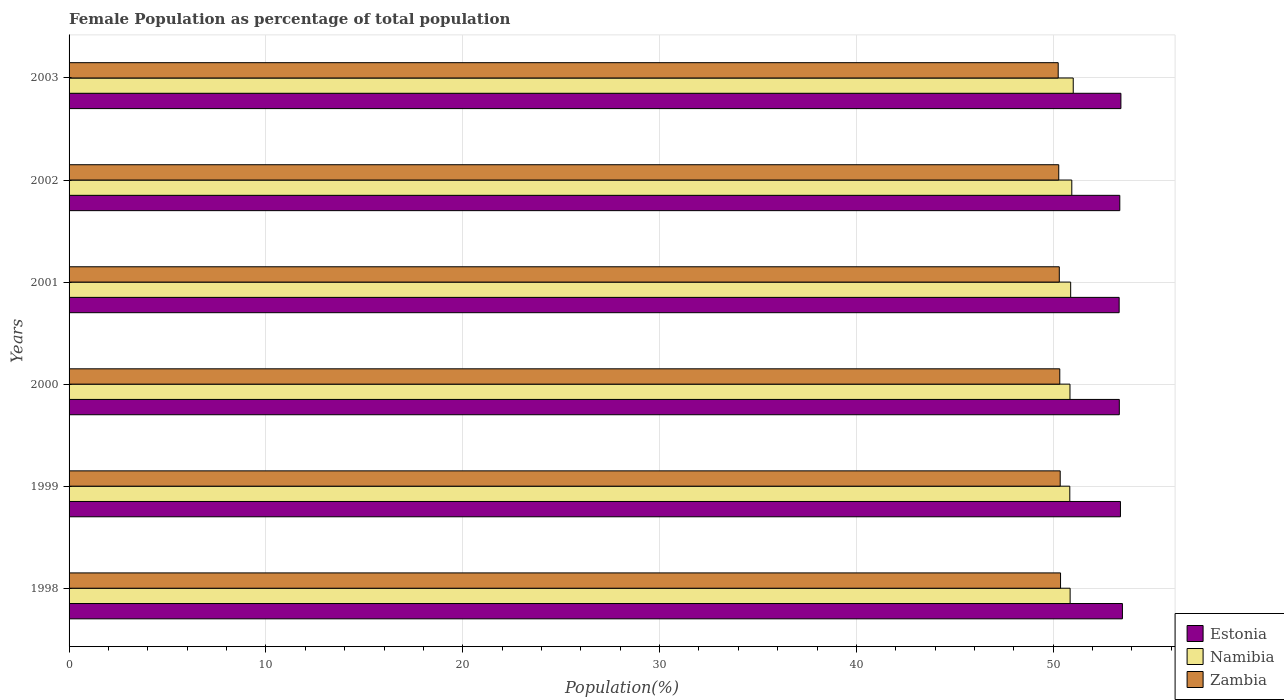Are the number of bars per tick equal to the number of legend labels?
Give a very brief answer. Yes. How many bars are there on the 2nd tick from the bottom?
Make the answer very short. 3. What is the label of the 3rd group of bars from the top?
Your answer should be compact. 2001. What is the female population in in Zambia in 2003?
Provide a short and direct response. 50.25. Across all years, what is the maximum female population in in Namibia?
Offer a very short reply. 51.02. Across all years, what is the minimum female population in in Zambia?
Offer a terse response. 50.25. In which year was the female population in in Estonia maximum?
Offer a very short reply. 1998. What is the total female population in in Zambia in the graph?
Your response must be concise. 301.91. What is the difference between the female population in in Namibia in 1998 and that in 2000?
Your answer should be very brief. 0.01. What is the difference between the female population in in Estonia in 1998 and the female population in in Zambia in 1999?
Keep it short and to the point. 3.16. What is the average female population in in Zambia per year?
Keep it short and to the point. 50.32. In the year 2000, what is the difference between the female population in in Namibia and female population in in Zambia?
Make the answer very short. 0.52. In how many years, is the female population in in Namibia greater than 20 %?
Your answer should be very brief. 6. What is the ratio of the female population in in Zambia in 1998 to that in 1999?
Provide a short and direct response. 1. Is the difference between the female population in in Namibia in 1999 and 2000 greater than the difference between the female population in in Zambia in 1999 and 2000?
Make the answer very short. No. What is the difference between the highest and the second highest female population in in Namibia?
Keep it short and to the point. 0.07. What is the difference between the highest and the lowest female population in in Namibia?
Make the answer very short. 0.17. What does the 2nd bar from the top in 1998 represents?
Ensure brevity in your answer.  Namibia. What does the 3rd bar from the bottom in 2000 represents?
Offer a very short reply. Zambia. Is it the case that in every year, the sum of the female population in in Namibia and female population in in Zambia is greater than the female population in in Estonia?
Give a very brief answer. Yes. How many bars are there?
Offer a terse response. 18. Are all the bars in the graph horizontal?
Keep it short and to the point. Yes. How many years are there in the graph?
Give a very brief answer. 6. What is the difference between two consecutive major ticks on the X-axis?
Provide a short and direct response. 10. Does the graph contain any zero values?
Your answer should be very brief. No. Does the graph contain grids?
Ensure brevity in your answer.  Yes. Where does the legend appear in the graph?
Your answer should be very brief. Bottom right. How are the legend labels stacked?
Offer a very short reply. Vertical. What is the title of the graph?
Make the answer very short. Female Population as percentage of total population. Does "European Union" appear as one of the legend labels in the graph?
Offer a terse response. No. What is the label or title of the X-axis?
Offer a terse response. Population(%). What is the Population(%) of Estonia in 1998?
Make the answer very short. 53.52. What is the Population(%) in Namibia in 1998?
Your response must be concise. 50.86. What is the Population(%) in Zambia in 1998?
Give a very brief answer. 50.37. What is the Population(%) in Estonia in 1999?
Your answer should be very brief. 53.42. What is the Population(%) of Namibia in 1999?
Provide a succinct answer. 50.84. What is the Population(%) of Zambia in 1999?
Give a very brief answer. 50.36. What is the Population(%) of Estonia in 2000?
Your response must be concise. 53.36. What is the Population(%) in Namibia in 2000?
Provide a short and direct response. 50.85. What is the Population(%) in Zambia in 2000?
Your answer should be compact. 50.33. What is the Population(%) of Estonia in 2001?
Make the answer very short. 53.35. What is the Population(%) in Namibia in 2001?
Your answer should be compact. 50.89. What is the Population(%) of Zambia in 2001?
Provide a succinct answer. 50.31. What is the Population(%) of Estonia in 2002?
Your answer should be compact. 53.38. What is the Population(%) in Namibia in 2002?
Your response must be concise. 50.94. What is the Population(%) of Zambia in 2002?
Keep it short and to the point. 50.28. What is the Population(%) of Estonia in 2003?
Your answer should be very brief. 53.44. What is the Population(%) in Namibia in 2003?
Provide a succinct answer. 51.02. What is the Population(%) in Zambia in 2003?
Provide a succinct answer. 50.25. Across all years, what is the maximum Population(%) of Estonia?
Keep it short and to the point. 53.52. Across all years, what is the maximum Population(%) of Namibia?
Provide a succinct answer. 51.02. Across all years, what is the maximum Population(%) in Zambia?
Offer a very short reply. 50.37. Across all years, what is the minimum Population(%) of Estonia?
Your answer should be compact. 53.35. Across all years, what is the minimum Population(%) of Namibia?
Provide a succinct answer. 50.84. Across all years, what is the minimum Population(%) in Zambia?
Your response must be concise. 50.25. What is the total Population(%) in Estonia in the graph?
Provide a succinct answer. 320.47. What is the total Population(%) of Namibia in the graph?
Make the answer very short. 305.41. What is the total Population(%) in Zambia in the graph?
Provide a succinct answer. 301.91. What is the difference between the Population(%) of Estonia in 1998 and that in 1999?
Make the answer very short. 0.1. What is the difference between the Population(%) in Namibia in 1998 and that in 1999?
Your response must be concise. 0.02. What is the difference between the Population(%) in Zambia in 1998 and that in 1999?
Your answer should be very brief. 0.02. What is the difference between the Population(%) of Estonia in 1998 and that in 2000?
Your response must be concise. 0.16. What is the difference between the Population(%) of Namibia in 1998 and that in 2000?
Provide a succinct answer. 0.01. What is the difference between the Population(%) in Zambia in 1998 and that in 2000?
Your answer should be compact. 0.04. What is the difference between the Population(%) in Estonia in 1998 and that in 2001?
Your response must be concise. 0.17. What is the difference between the Population(%) of Namibia in 1998 and that in 2001?
Make the answer very short. -0.03. What is the difference between the Population(%) in Zambia in 1998 and that in 2001?
Provide a succinct answer. 0.06. What is the difference between the Population(%) of Estonia in 1998 and that in 2002?
Your answer should be very brief. 0.13. What is the difference between the Population(%) of Namibia in 1998 and that in 2002?
Your answer should be compact. -0.09. What is the difference between the Population(%) of Zambia in 1998 and that in 2002?
Your response must be concise. 0.09. What is the difference between the Population(%) in Estonia in 1998 and that in 2003?
Your response must be concise. 0.08. What is the difference between the Population(%) in Namibia in 1998 and that in 2003?
Offer a very short reply. -0.16. What is the difference between the Population(%) of Zambia in 1998 and that in 2003?
Provide a short and direct response. 0.12. What is the difference between the Population(%) of Estonia in 1999 and that in 2000?
Offer a terse response. 0.06. What is the difference between the Population(%) of Namibia in 1999 and that in 2000?
Your answer should be very brief. -0.01. What is the difference between the Population(%) in Zambia in 1999 and that in 2000?
Your response must be concise. 0.02. What is the difference between the Population(%) in Estonia in 1999 and that in 2001?
Your answer should be very brief. 0.07. What is the difference between the Population(%) in Namibia in 1999 and that in 2001?
Ensure brevity in your answer.  -0.04. What is the difference between the Population(%) of Zambia in 1999 and that in 2001?
Provide a succinct answer. 0.05. What is the difference between the Population(%) of Estonia in 1999 and that in 2002?
Make the answer very short. 0.03. What is the difference between the Population(%) of Namibia in 1999 and that in 2002?
Your answer should be very brief. -0.1. What is the difference between the Population(%) of Zambia in 1999 and that in 2002?
Give a very brief answer. 0.07. What is the difference between the Population(%) in Estonia in 1999 and that in 2003?
Your answer should be compact. -0.02. What is the difference between the Population(%) in Namibia in 1999 and that in 2003?
Your answer should be very brief. -0.17. What is the difference between the Population(%) in Zambia in 1999 and that in 2003?
Your response must be concise. 0.1. What is the difference between the Population(%) of Estonia in 2000 and that in 2001?
Provide a succinct answer. 0.01. What is the difference between the Population(%) of Namibia in 2000 and that in 2001?
Make the answer very short. -0.04. What is the difference between the Population(%) in Zambia in 2000 and that in 2001?
Provide a short and direct response. 0.02. What is the difference between the Population(%) in Estonia in 2000 and that in 2002?
Give a very brief answer. -0.02. What is the difference between the Population(%) in Namibia in 2000 and that in 2002?
Your answer should be very brief. -0.09. What is the difference between the Population(%) in Zambia in 2000 and that in 2002?
Your answer should be compact. 0.05. What is the difference between the Population(%) of Estonia in 2000 and that in 2003?
Your answer should be compact. -0.08. What is the difference between the Population(%) of Namibia in 2000 and that in 2003?
Offer a terse response. -0.17. What is the difference between the Population(%) in Zambia in 2000 and that in 2003?
Your answer should be compact. 0.08. What is the difference between the Population(%) of Estonia in 2001 and that in 2002?
Keep it short and to the point. -0.03. What is the difference between the Population(%) in Namibia in 2001 and that in 2002?
Keep it short and to the point. -0.06. What is the difference between the Population(%) in Zambia in 2001 and that in 2002?
Provide a succinct answer. 0.03. What is the difference between the Population(%) of Estonia in 2001 and that in 2003?
Keep it short and to the point. -0.09. What is the difference between the Population(%) in Namibia in 2001 and that in 2003?
Keep it short and to the point. -0.13. What is the difference between the Population(%) in Zambia in 2001 and that in 2003?
Offer a very short reply. 0.06. What is the difference between the Population(%) of Estonia in 2002 and that in 2003?
Offer a very short reply. -0.06. What is the difference between the Population(%) of Namibia in 2002 and that in 2003?
Make the answer very short. -0.07. What is the difference between the Population(%) in Zambia in 2002 and that in 2003?
Your response must be concise. 0.03. What is the difference between the Population(%) in Estonia in 1998 and the Population(%) in Namibia in 1999?
Make the answer very short. 2.67. What is the difference between the Population(%) in Estonia in 1998 and the Population(%) in Zambia in 1999?
Offer a terse response. 3.16. What is the difference between the Population(%) of Namibia in 1998 and the Population(%) of Zambia in 1999?
Provide a succinct answer. 0.5. What is the difference between the Population(%) of Estonia in 1998 and the Population(%) of Namibia in 2000?
Give a very brief answer. 2.66. What is the difference between the Population(%) in Estonia in 1998 and the Population(%) in Zambia in 2000?
Keep it short and to the point. 3.18. What is the difference between the Population(%) of Namibia in 1998 and the Population(%) of Zambia in 2000?
Your answer should be compact. 0.53. What is the difference between the Population(%) of Estonia in 1998 and the Population(%) of Namibia in 2001?
Provide a succinct answer. 2.63. What is the difference between the Population(%) of Estonia in 1998 and the Population(%) of Zambia in 2001?
Ensure brevity in your answer.  3.21. What is the difference between the Population(%) of Namibia in 1998 and the Population(%) of Zambia in 2001?
Provide a short and direct response. 0.55. What is the difference between the Population(%) in Estonia in 1998 and the Population(%) in Namibia in 2002?
Keep it short and to the point. 2.57. What is the difference between the Population(%) of Estonia in 1998 and the Population(%) of Zambia in 2002?
Provide a succinct answer. 3.23. What is the difference between the Population(%) in Namibia in 1998 and the Population(%) in Zambia in 2002?
Your answer should be compact. 0.58. What is the difference between the Population(%) in Estonia in 1998 and the Population(%) in Namibia in 2003?
Give a very brief answer. 2.5. What is the difference between the Population(%) of Estonia in 1998 and the Population(%) of Zambia in 2003?
Your answer should be very brief. 3.26. What is the difference between the Population(%) in Namibia in 1998 and the Population(%) in Zambia in 2003?
Offer a terse response. 0.61. What is the difference between the Population(%) of Estonia in 1999 and the Population(%) of Namibia in 2000?
Keep it short and to the point. 2.56. What is the difference between the Population(%) in Estonia in 1999 and the Population(%) in Zambia in 2000?
Provide a succinct answer. 3.08. What is the difference between the Population(%) of Namibia in 1999 and the Population(%) of Zambia in 2000?
Provide a succinct answer. 0.51. What is the difference between the Population(%) in Estonia in 1999 and the Population(%) in Namibia in 2001?
Your answer should be compact. 2.53. What is the difference between the Population(%) in Estonia in 1999 and the Population(%) in Zambia in 2001?
Provide a short and direct response. 3.11. What is the difference between the Population(%) of Namibia in 1999 and the Population(%) of Zambia in 2001?
Offer a terse response. 0.53. What is the difference between the Population(%) in Estonia in 1999 and the Population(%) in Namibia in 2002?
Your response must be concise. 2.47. What is the difference between the Population(%) in Estonia in 1999 and the Population(%) in Zambia in 2002?
Your answer should be very brief. 3.13. What is the difference between the Population(%) in Namibia in 1999 and the Population(%) in Zambia in 2002?
Ensure brevity in your answer.  0.56. What is the difference between the Population(%) in Estonia in 1999 and the Population(%) in Namibia in 2003?
Provide a short and direct response. 2.4. What is the difference between the Population(%) in Estonia in 1999 and the Population(%) in Zambia in 2003?
Provide a succinct answer. 3.16. What is the difference between the Population(%) of Namibia in 1999 and the Population(%) of Zambia in 2003?
Provide a short and direct response. 0.59. What is the difference between the Population(%) in Estonia in 2000 and the Population(%) in Namibia in 2001?
Your response must be concise. 2.47. What is the difference between the Population(%) in Estonia in 2000 and the Population(%) in Zambia in 2001?
Offer a terse response. 3.05. What is the difference between the Population(%) in Namibia in 2000 and the Population(%) in Zambia in 2001?
Your answer should be very brief. 0.54. What is the difference between the Population(%) in Estonia in 2000 and the Population(%) in Namibia in 2002?
Keep it short and to the point. 2.41. What is the difference between the Population(%) in Estonia in 2000 and the Population(%) in Zambia in 2002?
Your answer should be compact. 3.08. What is the difference between the Population(%) in Namibia in 2000 and the Population(%) in Zambia in 2002?
Your answer should be very brief. 0.57. What is the difference between the Population(%) in Estonia in 2000 and the Population(%) in Namibia in 2003?
Ensure brevity in your answer.  2.34. What is the difference between the Population(%) in Estonia in 2000 and the Population(%) in Zambia in 2003?
Keep it short and to the point. 3.1. What is the difference between the Population(%) in Namibia in 2000 and the Population(%) in Zambia in 2003?
Keep it short and to the point. 0.6. What is the difference between the Population(%) in Estonia in 2001 and the Population(%) in Namibia in 2002?
Provide a succinct answer. 2.41. What is the difference between the Population(%) of Estonia in 2001 and the Population(%) of Zambia in 2002?
Provide a short and direct response. 3.07. What is the difference between the Population(%) of Namibia in 2001 and the Population(%) of Zambia in 2002?
Offer a terse response. 0.61. What is the difference between the Population(%) of Estonia in 2001 and the Population(%) of Namibia in 2003?
Give a very brief answer. 2.33. What is the difference between the Population(%) in Estonia in 2001 and the Population(%) in Zambia in 2003?
Offer a very short reply. 3.1. What is the difference between the Population(%) in Namibia in 2001 and the Population(%) in Zambia in 2003?
Offer a terse response. 0.63. What is the difference between the Population(%) of Estonia in 2002 and the Population(%) of Namibia in 2003?
Offer a very short reply. 2.37. What is the difference between the Population(%) of Estonia in 2002 and the Population(%) of Zambia in 2003?
Give a very brief answer. 3.13. What is the difference between the Population(%) of Namibia in 2002 and the Population(%) of Zambia in 2003?
Your answer should be compact. 0.69. What is the average Population(%) of Estonia per year?
Your answer should be very brief. 53.41. What is the average Population(%) in Namibia per year?
Make the answer very short. 50.9. What is the average Population(%) of Zambia per year?
Your answer should be compact. 50.32. In the year 1998, what is the difference between the Population(%) in Estonia and Population(%) in Namibia?
Your response must be concise. 2.66. In the year 1998, what is the difference between the Population(%) in Estonia and Population(%) in Zambia?
Make the answer very short. 3.14. In the year 1998, what is the difference between the Population(%) of Namibia and Population(%) of Zambia?
Offer a terse response. 0.49. In the year 1999, what is the difference between the Population(%) in Estonia and Population(%) in Namibia?
Your answer should be very brief. 2.57. In the year 1999, what is the difference between the Population(%) in Estonia and Population(%) in Zambia?
Ensure brevity in your answer.  3.06. In the year 1999, what is the difference between the Population(%) in Namibia and Population(%) in Zambia?
Offer a very short reply. 0.49. In the year 2000, what is the difference between the Population(%) of Estonia and Population(%) of Namibia?
Your answer should be compact. 2.51. In the year 2000, what is the difference between the Population(%) in Estonia and Population(%) in Zambia?
Your answer should be compact. 3.02. In the year 2000, what is the difference between the Population(%) in Namibia and Population(%) in Zambia?
Offer a very short reply. 0.52. In the year 2001, what is the difference between the Population(%) of Estonia and Population(%) of Namibia?
Your response must be concise. 2.46. In the year 2001, what is the difference between the Population(%) of Estonia and Population(%) of Zambia?
Ensure brevity in your answer.  3.04. In the year 2001, what is the difference between the Population(%) in Namibia and Population(%) in Zambia?
Your answer should be very brief. 0.58. In the year 2002, what is the difference between the Population(%) in Estonia and Population(%) in Namibia?
Ensure brevity in your answer.  2.44. In the year 2002, what is the difference between the Population(%) of Estonia and Population(%) of Zambia?
Give a very brief answer. 3.1. In the year 2002, what is the difference between the Population(%) of Namibia and Population(%) of Zambia?
Your answer should be very brief. 0.66. In the year 2003, what is the difference between the Population(%) of Estonia and Population(%) of Namibia?
Provide a short and direct response. 2.42. In the year 2003, what is the difference between the Population(%) in Estonia and Population(%) in Zambia?
Provide a short and direct response. 3.19. In the year 2003, what is the difference between the Population(%) of Namibia and Population(%) of Zambia?
Offer a terse response. 0.76. What is the ratio of the Population(%) of Estonia in 1998 to that in 1999?
Provide a short and direct response. 1. What is the ratio of the Population(%) of Zambia in 1998 to that in 1999?
Your response must be concise. 1. What is the ratio of the Population(%) of Namibia in 1998 to that in 2000?
Ensure brevity in your answer.  1. What is the ratio of the Population(%) in Zambia in 1998 to that in 2002?
Your answer should be very brief. 1. What is the ratio of the Population(%) of Estonia in 1998 to that in 2003?
Offer a terse response. 1. What is the ratio of the Population(%) in Zambia in 1999 to that in 2000?
Provide a short and direct response. 1. What is the ratio of the Population(%) in Namibia in 1999 to that in 2002?
Offer a very short reply. 1. What is the ratio of the Population(%) in Zambia in 1999 to that in 2002?
Your answer should be compact. 1. What is the ratio of the Population(%) in Namibia in 1999 to that in 2003?
Make the answer very short. 1. What is the ratio of the Population(%) in Namibia in 2000 to that in 2002?
Give a very brief answer. 1. What is the ratio of the Population(%) in Estonia in 2000 to that in 2003?
Give a very brief answer. 1. What is the ratio of the Population(%) of Namibia in 2001 to that in 2002?
Provide a short and direct response. 1. What is the ratio of the Population(%) in Zambia in 2001 to that in 2003?
Make the answer very short. 1. What is the ratio of the Population(%) of Estonia in 2002 to that in 2003?
Offer a terse response. 1. What is the difference between the highest and the second highest Population(%) in Estonia?
Make the answer very short. 0.08. What is the difference between the highest and the second highest Population(%) in Namibia?
Your response must be concise. 0.07. What is the difference between the highest and the second highest Population(%) of Zambia?
Provide a succinct answer. 0.02. What is the difference between the highest and the lowest Population(%) of Estonia?
Provide a short and direct response. 0.17. What is the difference between the highest and the lowest Population(%) of Namibia?
Keep it short and to the point. 0.17. What is the difference between the highest and the lowest Population(%) of Zambia?
Give a very brief answer. 0.12. 